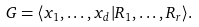<formula> <loc_0><loc_0><loc_500><loc_500>G = \langle x _ { 1 } , \dots , x _ { d } | R _ { 1 } , \dots , R _ { r } \rangle .</formula> 